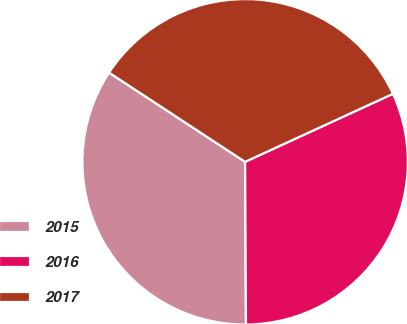<chart> <loc_0><loc_0><loc_500><loc_500><pie_chart><fcel>2015<fcel>2016<fcel>2017<nl><fcel>34.32%<fcel>31.78%<fcel>33.9%<nl></chart> 